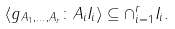Convert formula to latex. <formula><loc_0><loc_0><loc_500><loc_500>\langle g _ { A _ { 1 } , \dots , A _ { r } } \colon A _ { i } I _ { i } \rangle \subseteq \cap _ { i = 1 } ^ { r } I _ { i } .</formula> 